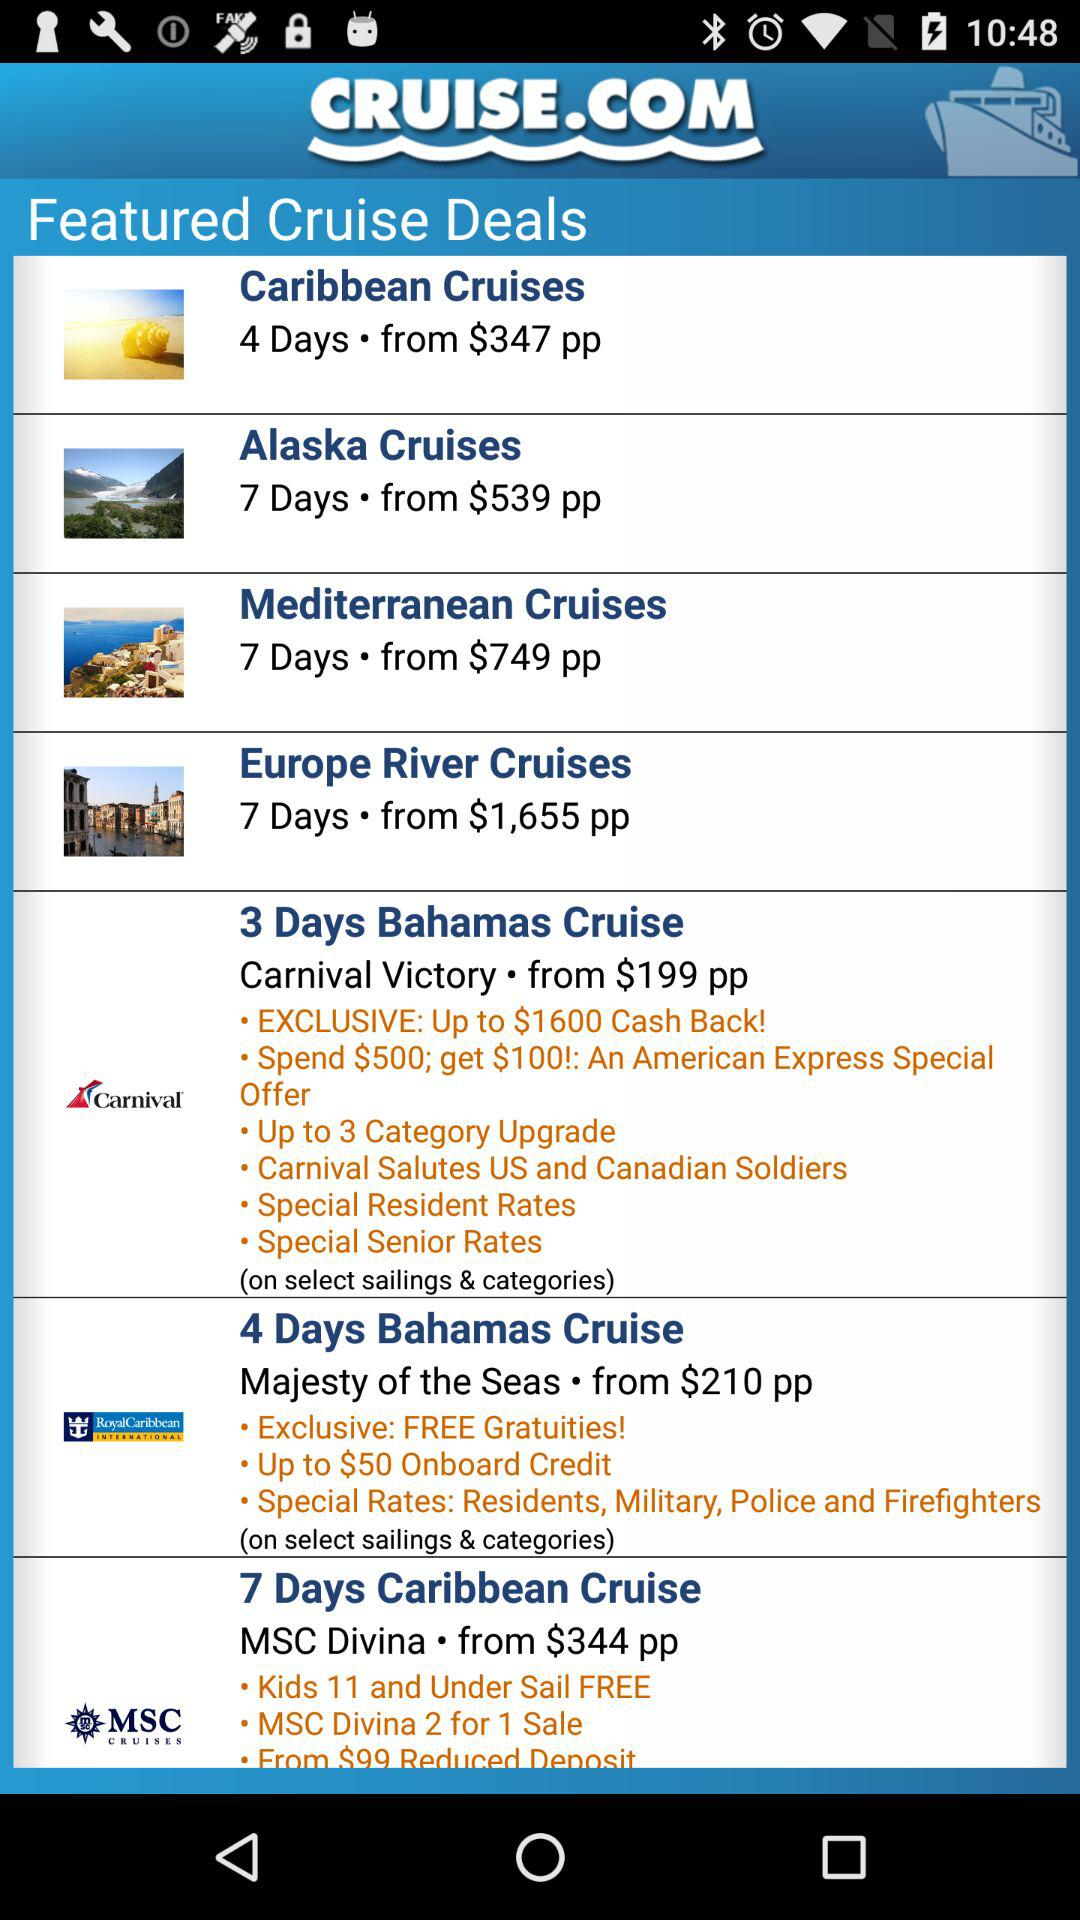How long will the Alaska cruise trip last? The Alaska cruise trip will last 7 days. 